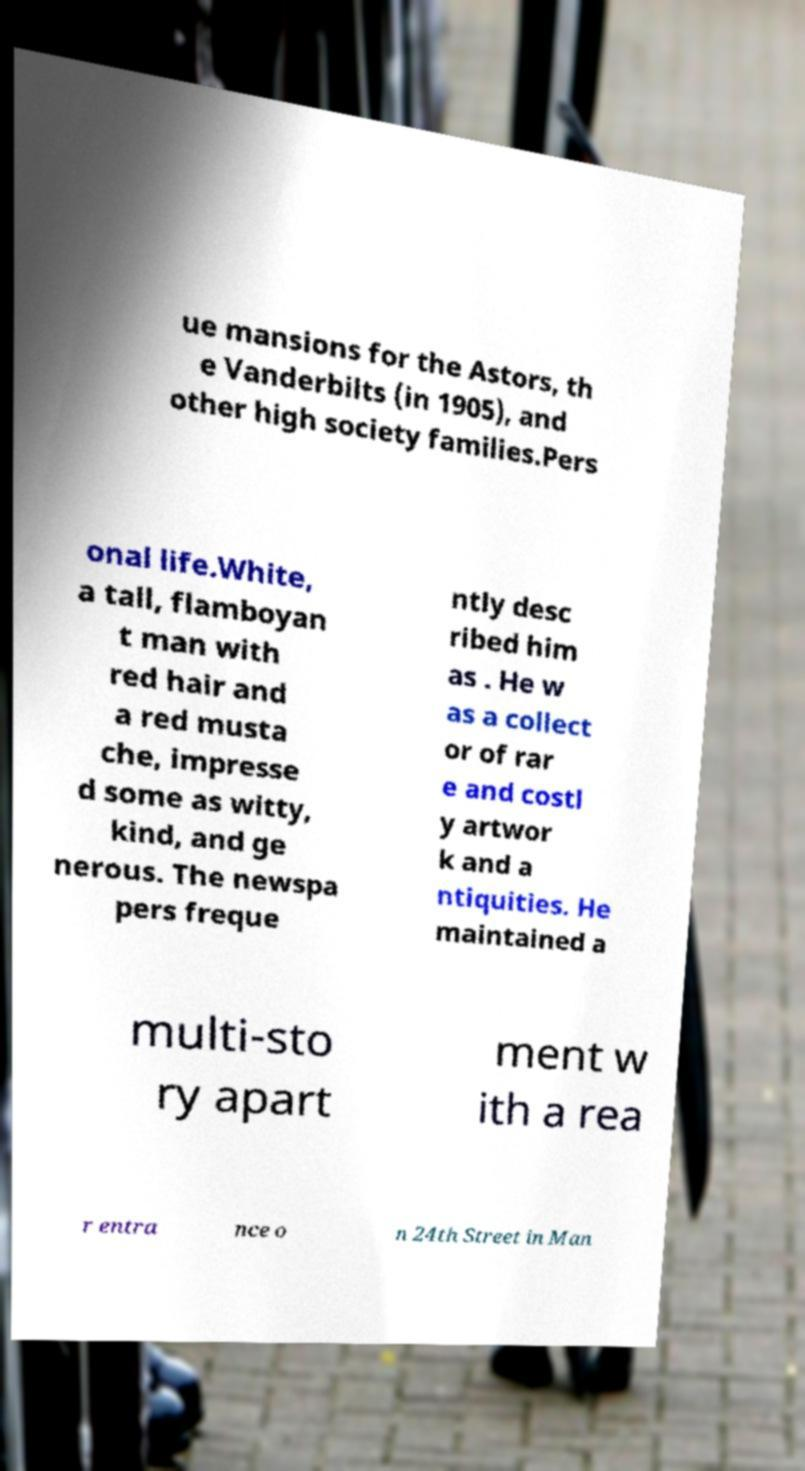Could you assist in decoding the text presented in this image and type it out clearly? ue mansions for the Astors, th e Vanderbilts (in 1905), and other high society families.Pers onal life.White, a tall, flamboyan t man with red hair and a red musta che, impresse d some as witty, kind, and ge nerous. The newspa pers freque ntly desc ribed him as . He w as a collect or of rar e and costl y artwor k and a ntiquities. He maintained a multi-sto ry apart ment w ith a rea r entra nce o n 24th Street in Man 